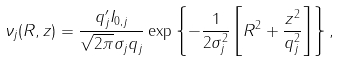Convert formula to latex. <formula><loc_0><loc_0><loc_500><loc_500>\nu _ { j } ( R , z ) = \frac { q ^ { \prime } _ { j } I _ { 0 , j } } { \sqrt { 2 \pi } \sigma _ { j } q _ { j } } \exp \left \{ - \frac { 1 } { 2 \sigma _ { j } ^ { 2 } } \left [ R ^ { 2 } + \frac { z ^ { 2 } } { q _ { j } ^ { 2 } } \right ] \right \} ,</formula> 